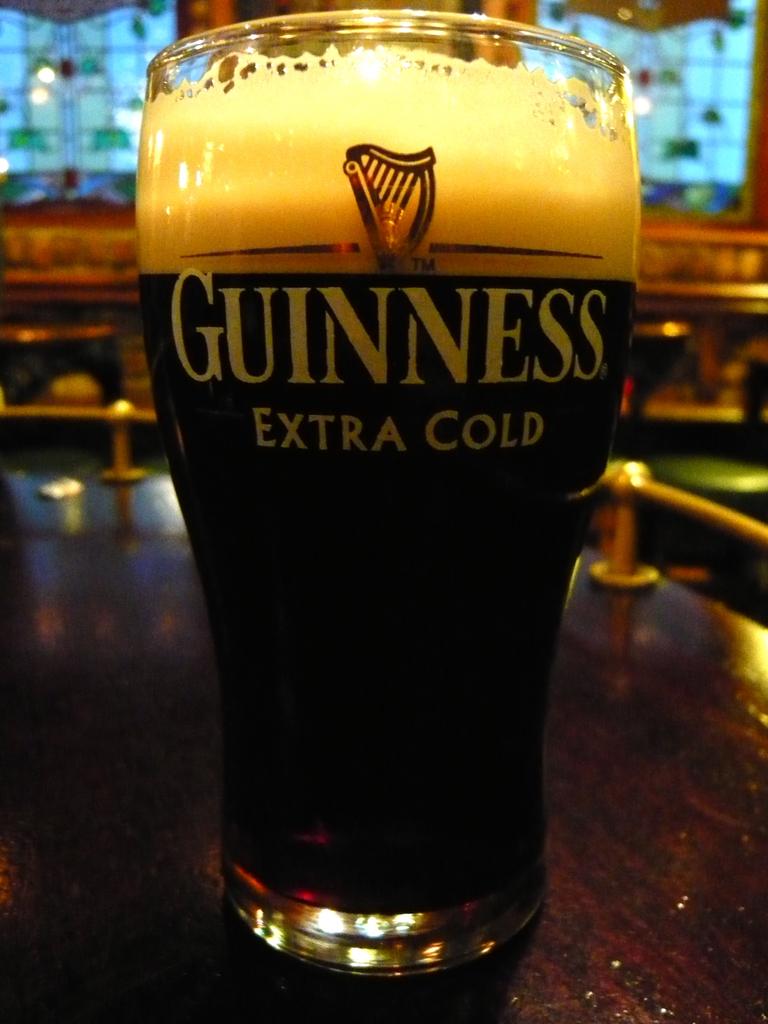What beer is in the glass?
Ensure brevity in your answer.  Guinness. What is spelled under guiness?
Provide a succinct answer. Extra cold. 